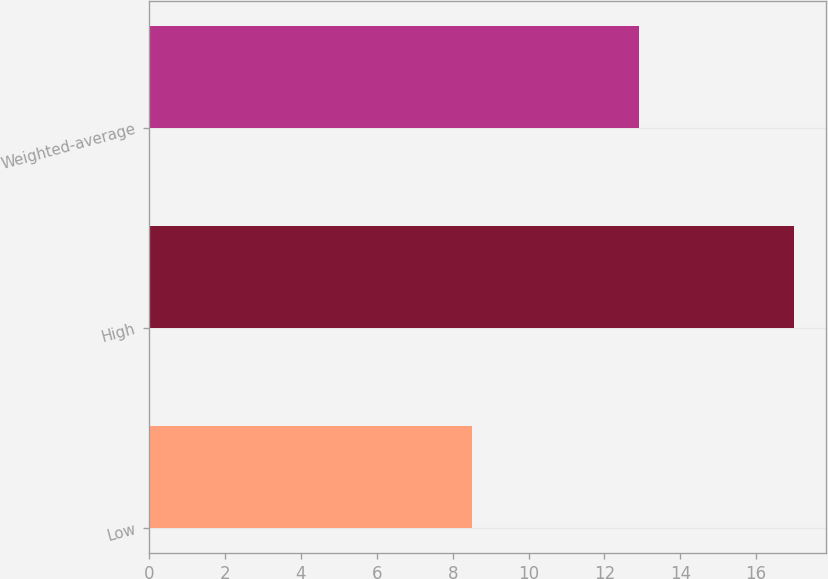Convert chart. <chart><loc_0><loc_0><loc_500><loc_500><bar_chart><fcel>Low<fcel>High<fcel>Weighted-average<nl><fcel>8.5<fcel>17<fcel>12.91<nl></chart> 